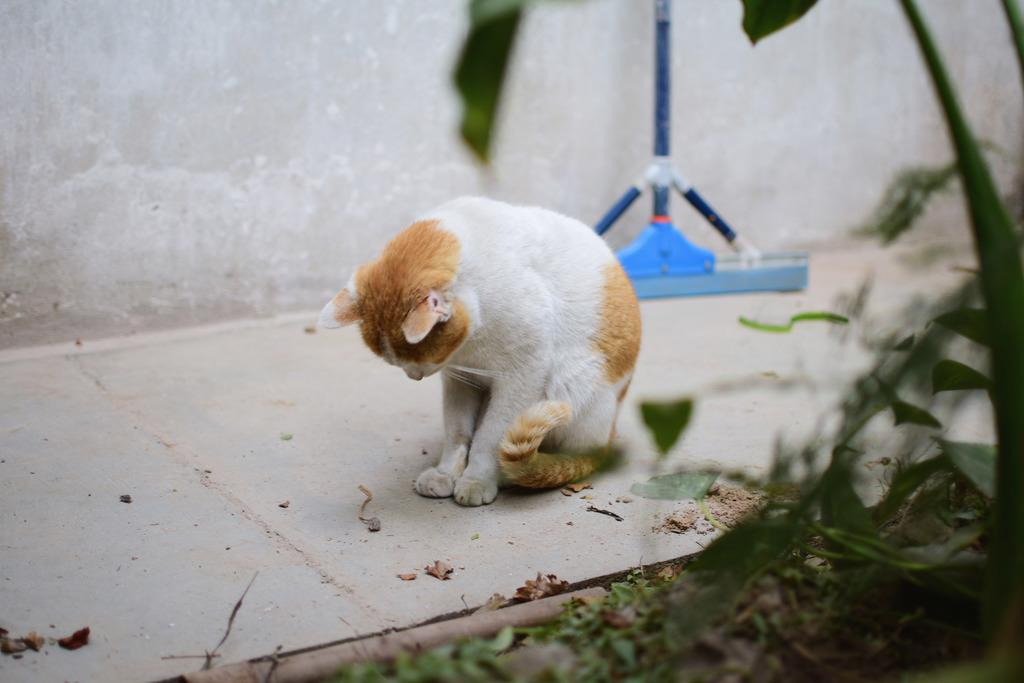What type of vegetation is on the right side of the image? There are plants on the right side of the image. What animal is in the middle of the image? There is a cat in the middle of the image. What is the color of the cat? The cat is white in color. What object is also in the middle of the image? There is a wiper in the middle of the image. What is the color of the wiper? The wiper is blue in color. How many turkeys can be seen eating seeds near the waves in the image? There are no turkeys, seeds, or waves present in the image. 